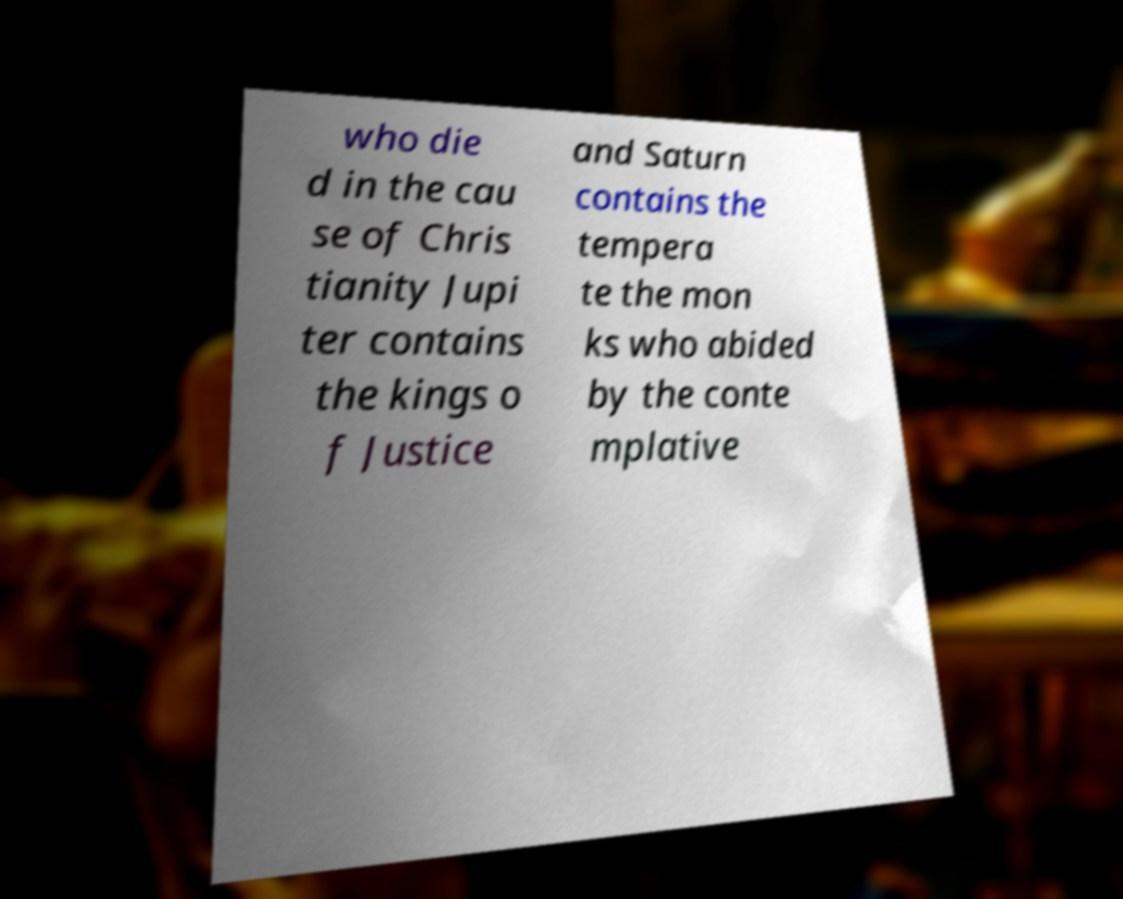What messages or text are displayed in this image? I need them in a readable, typed format. who die d in the cau se of Chris tianity Jupi ter contains the kings o f Justice and Saturn contains the tempera te the mon ks who abided by the conte mplative 